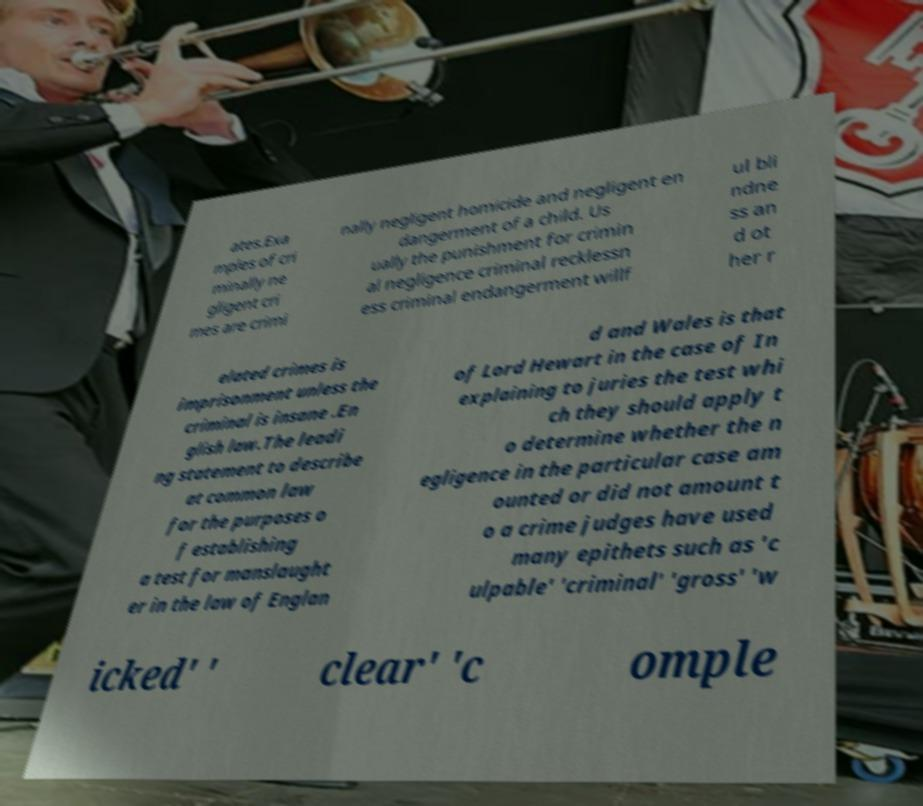For documentation purposes, I need the text within this image transcribed. Could you provide that? ates.Exa mples of cri minally ne gligent cri mes are crimi nally negligent homicide and negligent en dangerment of a child. Us ually the punishment for crimin al negligence criminal recklessn ess criminal endangerment willf ul bli ndne ss an d ot her r elated crimes is imprisonment unless the criminal is insane .En glish law.The leadi ng statement to describe at common law for the purposes o f establishing a test for manslaught er in the law of Englan d and Wales is that of Lord Hewart in the case of In explaining to juries the test whi ch they should apply t o determine whether the n egligence in the particular case am ounted or did not amount t o a crime judges have used many epithets such as 'c ulpable' 'criminal' 'gross' 'w icked' ' clear' 'c omple 